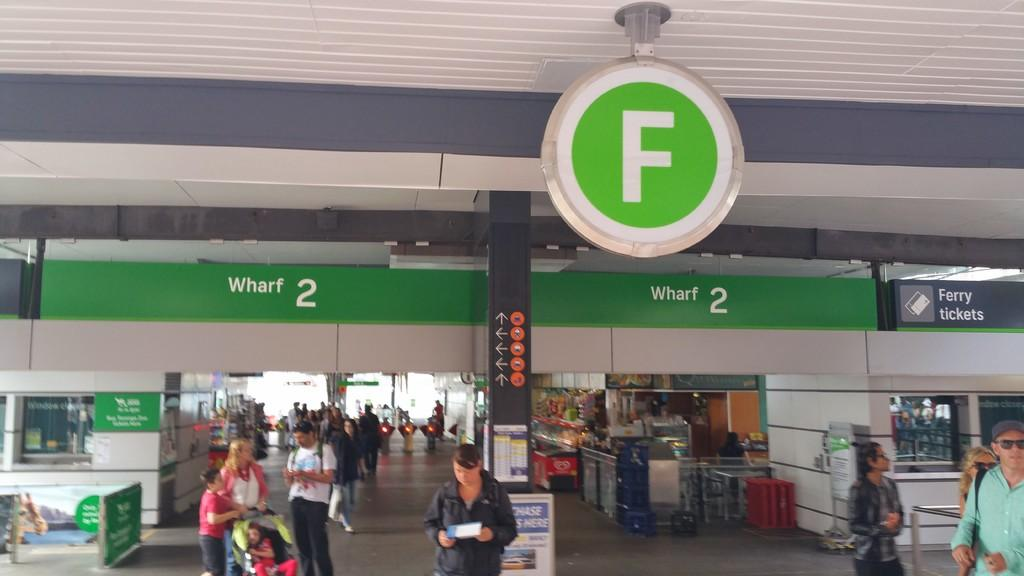<image>
Relay a brief, clear account of the picture shown. A sign that is hanging up, thatis green and white and has a large F on it. 